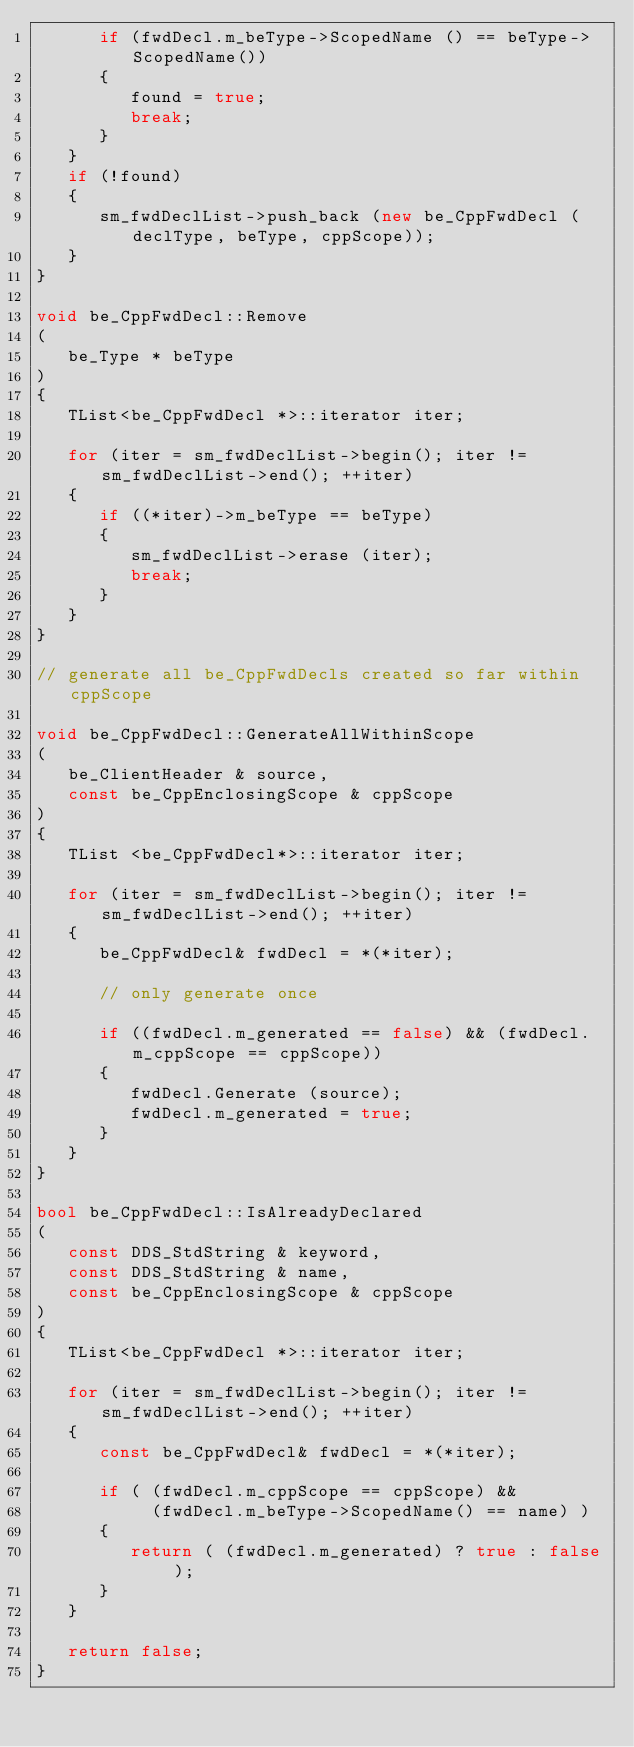Convert code to text. <code><loc_0><loc_0><loc_500><loc_500><_C++_>      if (fwdDecl.m_beType->ScopedName () == beType->ScopedName())
      {
         found = true;
         break;
      }
   }
   if (!found)
   {
      sm_fwdDeclList->push_back (new be_CppFwdDecl (declType, beType, cppScope));
   }
}

void be_CppFwdDecl::Remove
(
   be_Type * beType
)
{
   TList<be_CppFwdDecl *>::iterator iter;

   for (iter = sm_fwdDeclList->begin(); iter != sm_fwdDeclList->end(); ++iter)
   {
      if ((*iter)->m_beType == beType)
      {
         sm_fwdDeclList->erase (iter);
         break;
      }
   }
}

// generate all be_CppFwdDecls created so far within cppScope

void be_CppFwdDecl::GenerateAllWithinScope
(
   be_ClientHeader & source,
   const be_CppEnclosingScope & cppScope
)
{
   TList <be_CppFwdDecl*>::iterator iter;

   for (iter = sm_fwdDeclList->begin(); iter != sm_fwdDeclList->end(); ++iter)
   {
      be_CppFwdDecl& fwdDecl = *(*iter);

      // only generate once

      if ((fwdDecl.m_generated == false) && (fwdDecl.m_cppScope == cppScope))
      {
         fwdDecl.Generate (source);
         fwdDecl.m_generated = true;
      }
   }
}

bool be_CppFwdDecl::IsAlreadyDeclared
(
   const DDS_StdString & keyword,
   const DDS_StdString & name,
   const be_CppEnclosingScope & cppScope
)
{
   TList<be_CppFwdDecl *>::iterator iter;

   for (iter = sm_fwdDeclList->begin(); iter != sm_fwdDeclList->end(); ++iter)
   {
      const be_CppFwdDecl& fwdDecl = *(*iter);

      if ( (fwdDecl.m_cppScope == cppScope) &&
           (fwdDecl.m_beType->ScopedName() == name) )
      {
         return ( (fwdDecl.m_generated) ? true : false );
      }
   }

   return false;
}
</code> 